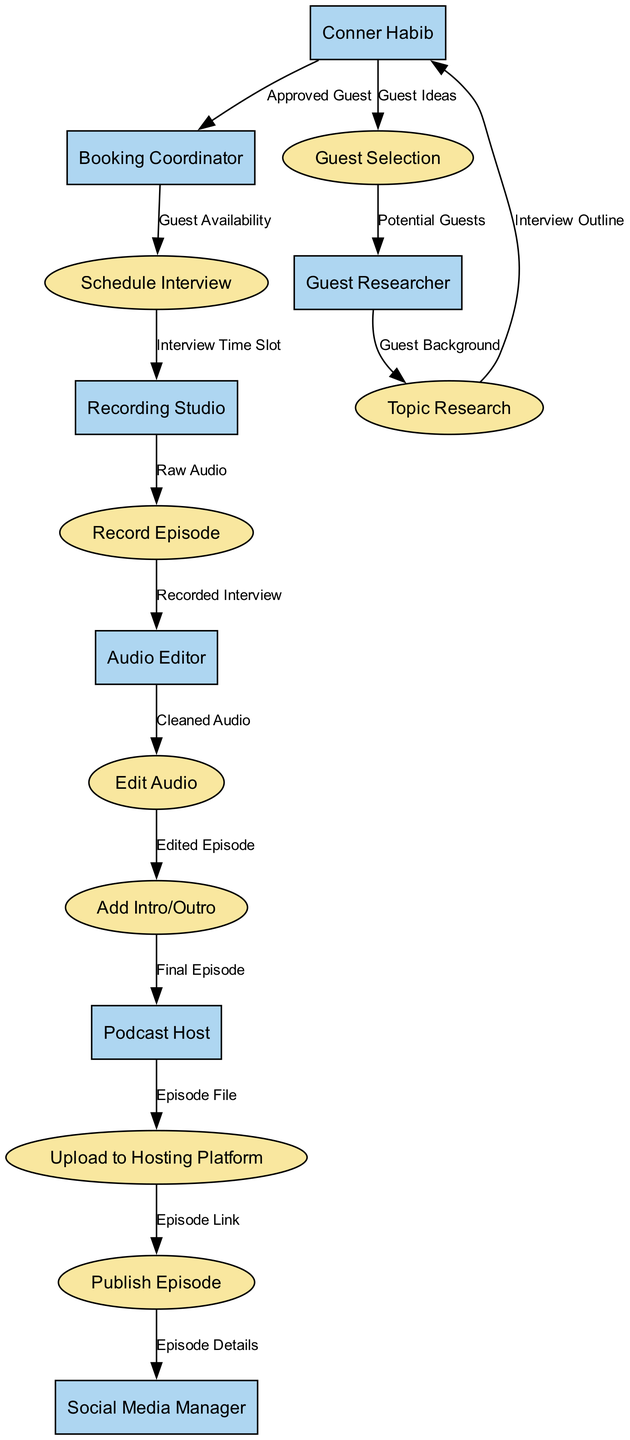What is the first process in the podcast production workflow? The first process is "Guest Selection," which follows after ideas for guests are provided by Conner Habib. This process is clearly identified in the diagram as the starting point of the workflow.
Answer: Guest Selection How many entities are involved in the diagram? By counting each unique entity listed in the diagram, we identify six distinct entities: Conner Habib, Guest Researcher, Booking Coordinator, Recording Studio, Audio Editor, Podcast Host, and Social Media Manager. Therefore, the total number of entities is six.
Answer: 6 What flows from the "Audio Editor" to "Edit Audio"? The flow from the "Audio Editor" to "Edit Audio" is a data flow labeled "Cleaned Audio," indicating the specific information passed between these processes in the workflow.
Answer: Cleaned Audio Who is responsible for publishing the episode? The "Social Media Manager" is responsible for publishing the episode as indicated by the flow from "Publish Episode" to this entity, signifying their role in handling episode details after publication.
Answer: Social Media Manager What is the last process before publication? The last process before the episode is published is "Upload to Hosting Platform." This process occurs immediately before the information is sent out for public access and is crucial for making the episode available to listeners.
Answer: Upload to Hosting Platform What is the relationship between "Topic Research" and "Conner Habib"? The relationship is that "Topic Research" sends an "Interview Outline" to "Conner Habib," meaning that the outlines created from topic research are provided to him for review or approval before proceeding.
Answer: Interview Outline How does the "Recording Studio" receive the interview time slot? The "Recording Studio" receives the "Interview Time Slot" from the "Schedule Interview" process, which indicates that scheduling must occur to allocate time to record the episode. This connection shows the workflow progression in terms of scheduling.
Answer: Interview Time Slot What does "Add Intro/Outro" receive as input from "Edit Audio"? The input to "Add Intro/Outro" from "Edit Audio" is labeled "Edited Episode," which signifies that the edited version of the episode is what will have additional elements, like intros and outros, added before publication.
Answer: Edited Episode 